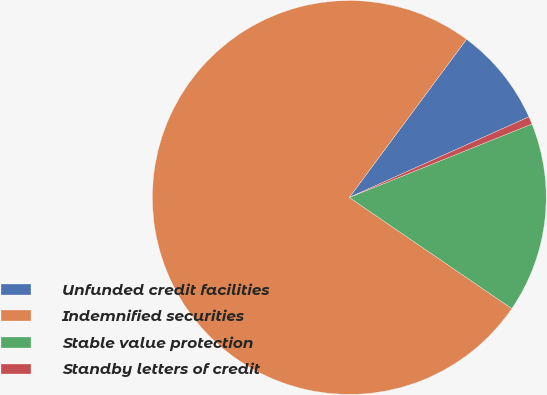Convert chart to OTSL. <chart><loc_0><loc_0><loc_500><loc_500><pie_chart><fcel>Unfunded credit facilities<fcel>Indemnified securities<fcel>Stable value protection<fcel>Standby letters of credit<nl><fcel>8.13%<fcel>75.62%<fcel>15.63%<fcel>0.63%<nl></chart> 